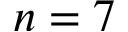Convert formula to latex. <formula><loc_0><loc_0><loc_500><loc_500>n = 7</formula> 